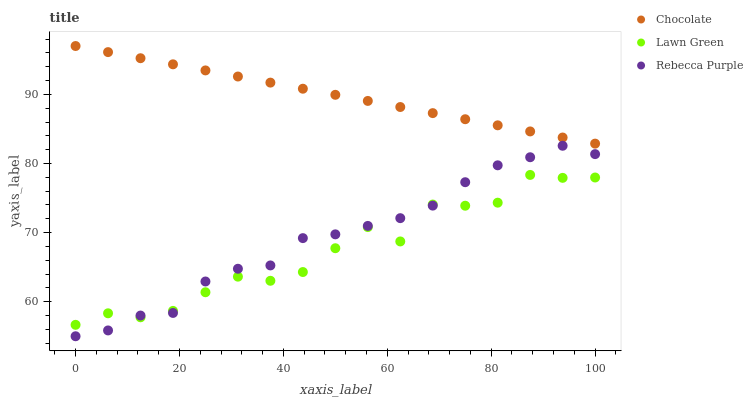Does Lawn Green have the minimum area under the curve?
Answer yes or no. Yes. Does Chocolate have the maximum area under the curve?
Answer yes or no. Yes. Does Rebecca Purple have the minimum area under the curve?
Answer yes or no. No. Does Rebecca Purple have the maximum area under the curve?
Answer yes or no. No. Is Chocolate the smoothest?
Answer yes or no. Yes. Is Lawn Green the roughest?
Answer yes or no. Yes. Is Rebecca Purple the smoothest?
Answer yes or no. No. Is Rebecca Purple the roughest?
Answer yes or no. No. Does Rebecca Purple have the lowest value?
Answer yes or no. Yes. Does Chocolate have the lowest value?
Answer yes or no. No. Does Chocolate have the highest value?
Answer yes or no. Yes. Does Rebecca Purple have the highest value?
Answer yes or no. No. Is Rebecca Purple less than Chocolate?
Answer yes or no. Yes. Is Chocolate greater than Rebecca Purple?
Answer yes or no. Yes. Does Lawn Green intersect Rebecca Purple?
Answer yes or no. Yes. Is Lawn Green less than Rebecca Purple?
Answer yes or no. No. Is Lawn Green greater than Rebecca Purple?
Answer yes or no. No. Does Rebecca Purple intersect Chocolate?
Answer yes or no. No. 